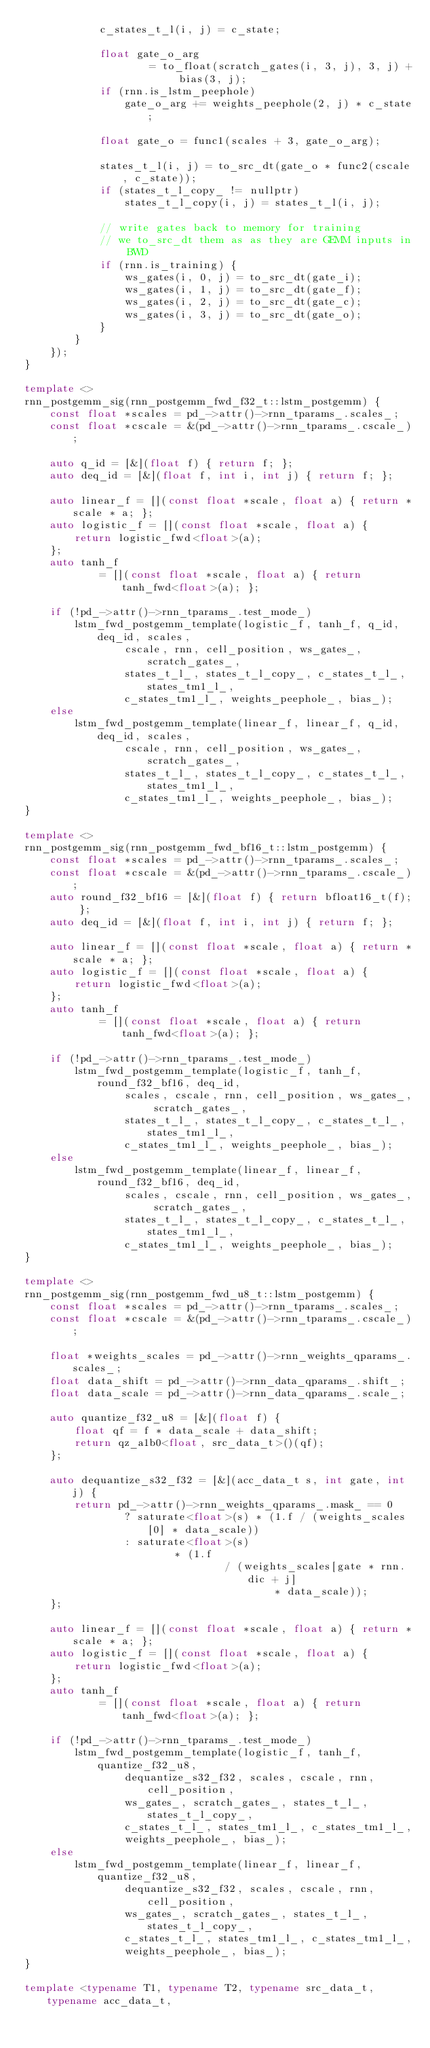<code> <loc_0><loc_0><loc_500><loc_500><_C++_>            c_states_t_l(i, j) = c_state;

            float gate_o_arg
                    = to_float(scratch_gates(i, 3, j), 3, j) + bias(3, j);
            if (rnn.is_lstm_peephole)
                gate_o_arg += weights_peephole(2, j) * c_state;

            float gate_o = func1(scales + 3, gate_o_arg);

            states_t_l(i, j) = to_src_dt(gate_o * func2(cscale, c_state));
            if (states_t_l_copy_ != nullptr)
                states_t_l_copy(i, j) = states_t_l(i, j);

            // write gates back to memory for training
            // we to_src_dt them as as they are GEMM inputs in BWD
            if (rnn.is_training) {
                ws_gates(i, 0, j) = to_src_dt(gate_i);
                ws_gates(i, 1, j) = to_src_dt(gate_f);
                ws_gates(i, 2, j) = to_src_dt(gate_c);
                ws_gates(i, 3, j) = to_src_dt(gate_o);
            }
        }
    });
}

template <>
rnn_postgemm_sig(rnn_postgemm_fwd_f32_t::lstm_postgemm) {
    const float *scales = pd_->attr()->rnn_tparams_.scales_;
    const float *cscale = &(pd_->attr()->rnn_tparams_.cscale_);

    auto q_id = [&](float f) { return f; };
    auto deq_id = [&](float f, int i, int j) { return f; };

    auto linear_f = [](const float *scale, float a) { return *scale * a; };
    auto logistic_f = [](const float *scale, float a) {
        return logistic_fwd<float>(a);
    };
    auto tanh_f
            = [](const float *scale, float a) { return tanh_fwd<float>(a); };

    if (!pd_->attr()->rnn_tparams_.test_mode_)
        lstm_fwd_postgemm_template(logistic_f, tanh_f, q_id, deq_id, scales,
                cscale, rnn, cell_position, ws_gates_, scratch_gates_,
                states_t_l_, states_t_l_copy_, c_states_t_l_, states_tm1_l_,
                c_states_tm1_l_, weights_peephole_, bias_);
    else
        lstm_fwd_postgemm_template(linear_f, linear_f, q_id, deq_id, scales,
                cscale, rnn, cell_position, ws_gates_, scratch_gates_,
                states_t_l_, states_t_l_copy_, c_states_t_l_, states_tm1_l_,
                c_states_tm1_l_, weights_peephole_, bias_);
}

template <>
rnn_postgemm_sig(rnn_postgemm_fwd_bf16_t::lstm_postgemm) {
    const float *scales = pd_->attr()->rnn_tparams_.scales_;
    const float *cscale = &(pd_->attr()->rnn_tparams_.cscale_);
    auto round_f32_bf16 = [&](float f) { return bfloat16_t(f); };
    auto deq_id = [&](float f, int i, int j) { return f; };

    auto linear_f = [](const float *scale, float a) { return *scale * a; };
    auto logistic_f = [](const float *scale, float a) {
        return logistic_fwd<float>(a);
    };
    auto tanh_f
            = [](const float *scale, float a) { return tanh_fwd<float>(a); };

    if (!pd_->attr()->rnn_tparams_.test_mode_)
        lstm_fwd_postgemm_template(logistic_f, tanh_f, round_f32_bf16, deq_id,
                scales, cscale, rnn, cell_position, ws_gates_, scratch_gates_,
                states_t_l_, states_t_l_copy_, c_states_t_l_, states_tm1_l_,
                c_states_tm1_l_, weights_peephole_, bias_);
    else
        lstm_fwd_postgemm_template(linear_f, linear_f, round_f32_bf16, deq_id,
                scales, cscale, rnn, cell_position, ws_gates_, scratch_gates_,
                states_t_l_, states_t_l_copy_, c_states_t_l_, states_tm1_l_,
                c_states_tm1_l_, weights_peephole_, bias_);
}

template <>
rnn_postgemm_sig(rnn_postgemm_fwd_u8_t::lstm_postgemm) {
    const float *scales = pd_->attr()->rnn_tparams_.scales_;
    const float *cscale = &(pd_->attr()->rnn_tparams_.cscale_);

    float *weights_scales = pd_->attr()->rnn_weights_qparams_.scales_;
    float data_shift = pd_->attr()->rnn_data_qparams_.shift_;
    float data_scale = pd_->attr()->rnn_data_qparams_.scale_;

    auto quantize_f32_u8 = [&](float f) {
        float qf = f * data_scale + data_shift;
        return qz_a1b0<float, src_data_t>()(qf);
    };

    auto dequantize_s32_f32 = [&](acc_data_t s, int gate, int j) {
        return pd_->attr()->rnn_weights_qparams_.mask_ == 0
                ? saturate<float>(s) * (1.f / (weights_scales[0] * data_scale))
                : saturate<float>(s)
                        * (1.f
                                / (weights_scales[gate * rnn.dic + j]
                                        * data_scale));
    };

    auto linear_f = [](const float *scale, float a) { return *scale * a; };
    auto logistic_f = [](const float *scale, float a) {
        return logistic_fwd<float>(a);
    };
    auto tanh_f
            = [](const float *scale, float a) { return tanh_fwd<float>(a); };

    if (!pd_->attr()->rnn_tparams_.test_mode_)
        lstm_fwd_postgemm_template(logistic_f, tanh_f, quantize_f32_u8,
                dequantize_s32_f32, scales, cscale, rnn, cell_position,
                ws_gates_, scratch_gates_, states_t_l_, states_t_l_copy_,
                c_states_t_l_, states_tm1_l_, c_states_tm1_l_,
                weights_peephole_, bias_);
    else
        lstm_fwd_postgemm_template(linear_f, linear_f, quantize_f32_u8,
                dequantize_s32_f32, scales, cscale, rnn, cell_position,
                ws_gates_, scratch_gates_, states_t_l_, states_t_l_copy_,
                c_states_t_l_, states_tm1_l_, c_states_tm1_l_,
                weights_peephole_, bias_);
}

template <typename T1, typename T2, typename src_data_t, typename acc_data_t,</code> 